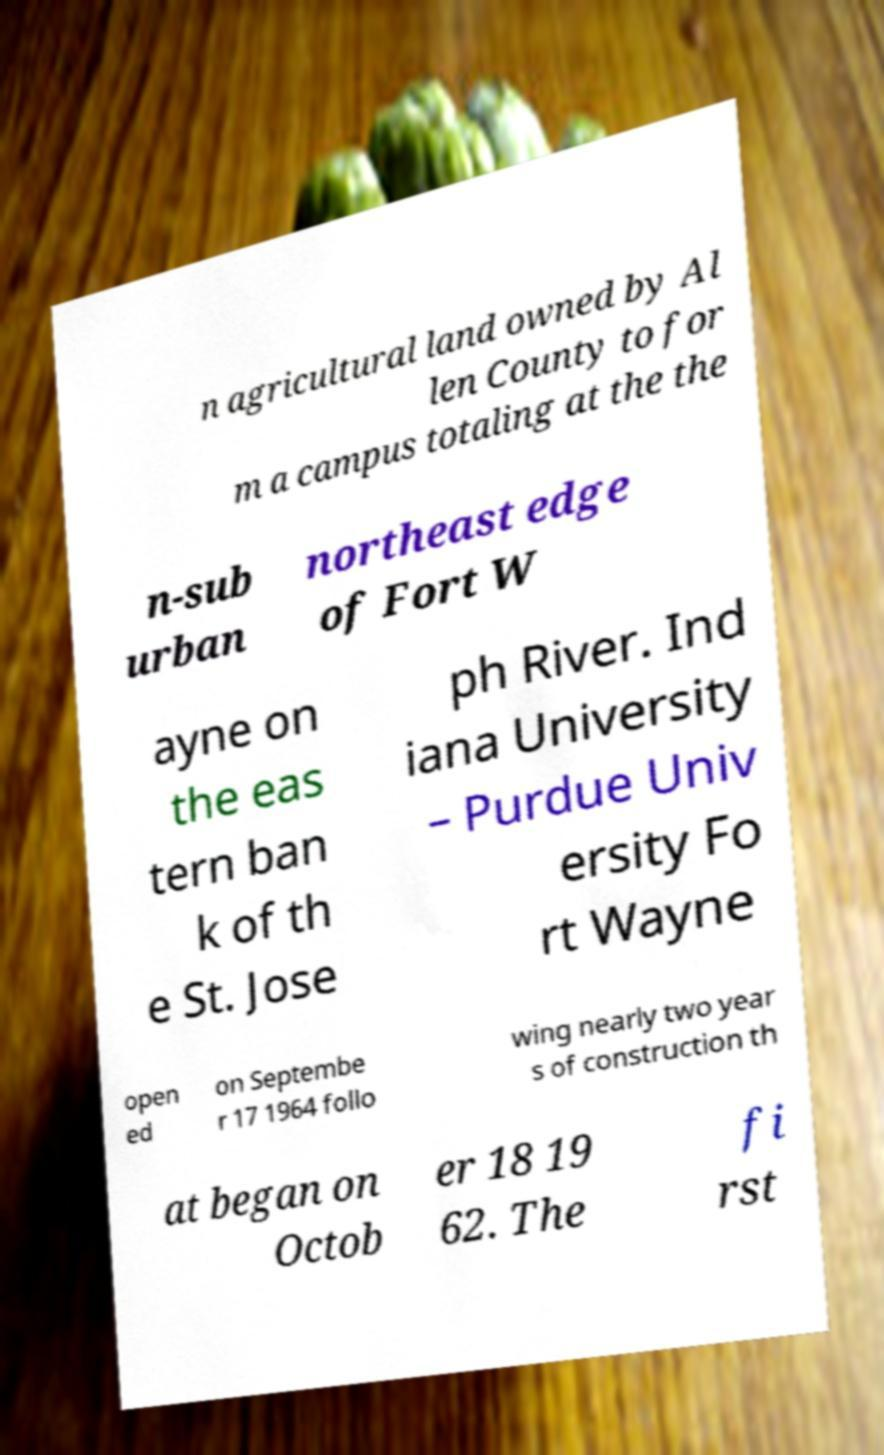What messages or text are displayed in this image? I need them in a readable, typed format. n agricultural land owned by Al len County to for m a campus totaling at the the n-sub urban northeast edge of Fort W ayne on the eas tern ban k of th e St. Jose ph River. Ind iana University – Purdue Univ ersity Fo rt Wayne open ed on Septembe r 17 1964 follo wing nearly two year s of construction th at began on Octob er 18 19 62. The fi rst 